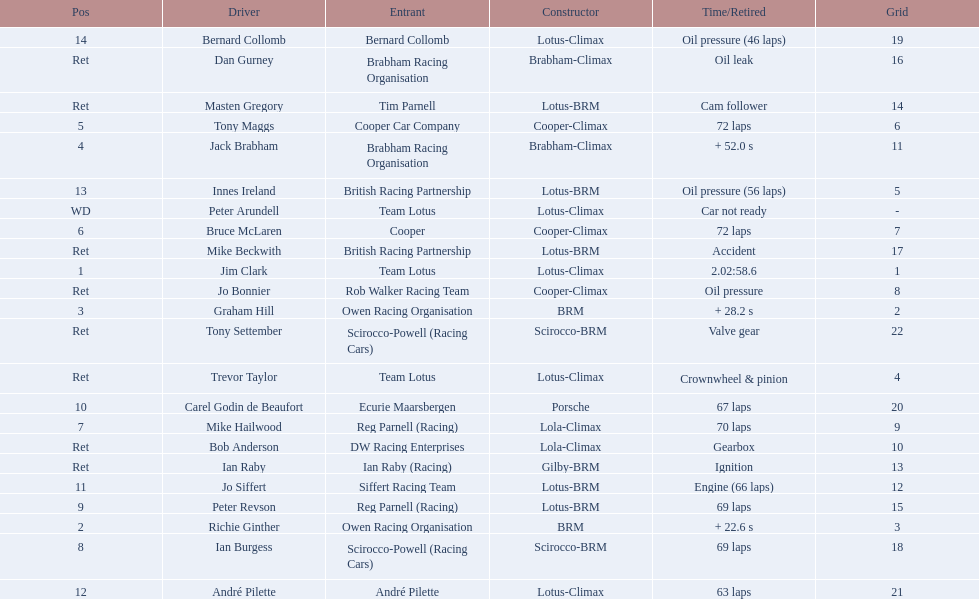Who are all the drivers? Jim Clark, Richie Ginther, Graham Hill, Jack Brabham, Tony Maggs, Bruce McLaren, Mike Hailwood, Ian Burgess, Peter Revson, Carel Godin de Beaufort, Jo Siffert, André Pilette, Innes Ireland, Bernard Collomb, Ian Raby, Dan Gurney, Mike Beckwith, Masten Gregory, Trevor Taylor, Jo Bonnier, Tony Settember, Bob Anderson, Peter Arundell. Which drove a cooper-climax? Tony Maggs, Bruce McLaren, Jo Bonnier. Of those, who was the top finisher? Tony Maggs. 